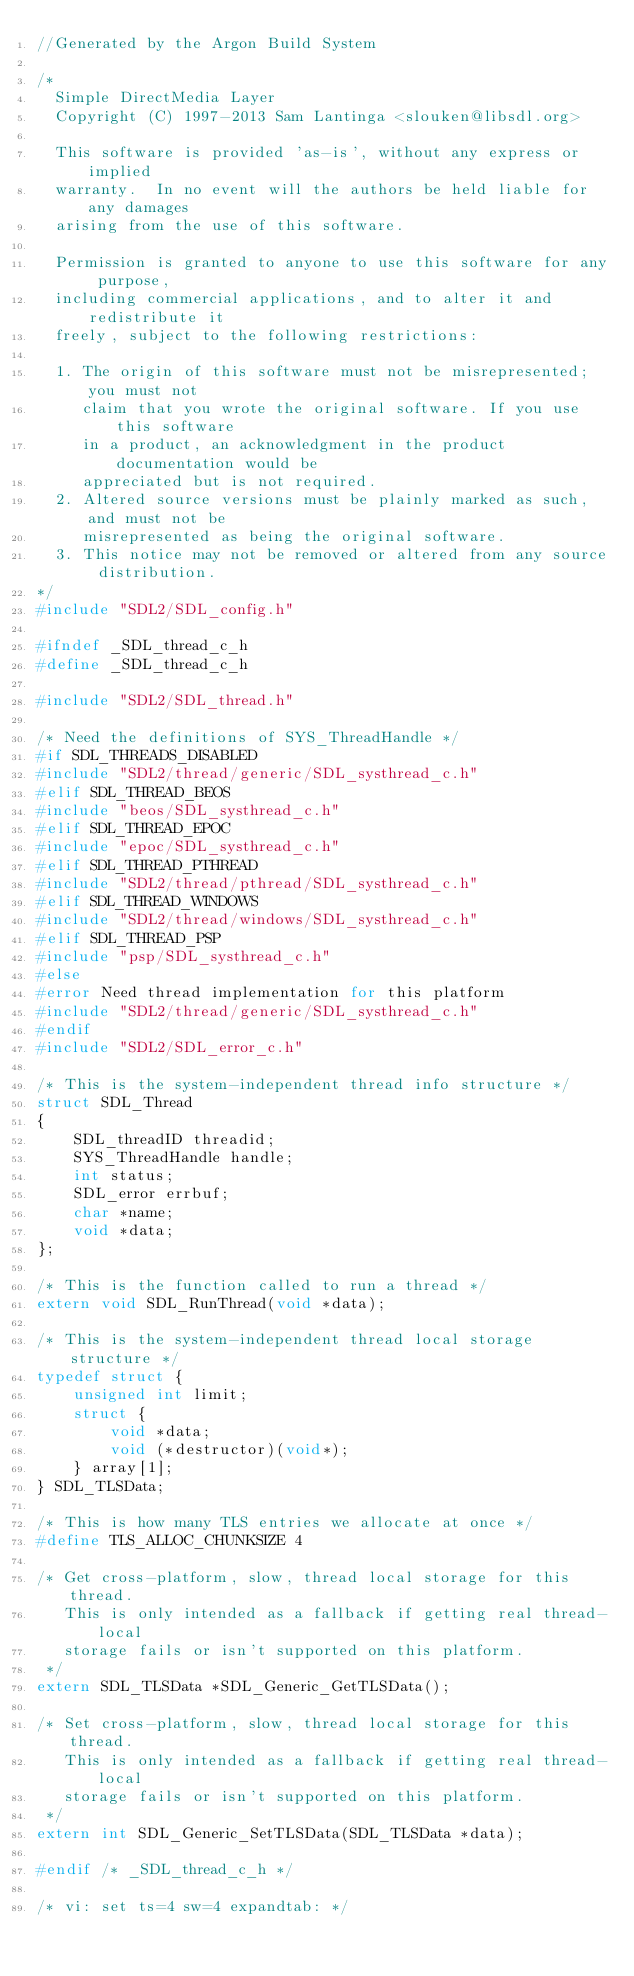Convert code to text. <code><loc_0><loc_0><loc_500><loc_500><_C_>//Generated by the Argon Build System

/*
  Simple DirectMedia Layer
  Copyright (C) 1997-2013 Sam Lantinga <slouken@libsdl.org>

  This software is provided 'as-is', without any express or implied
  warranty.  In no event will the authors be held liable for any damages
  arising from the use of this software.

  Permission is granted to anyone to use this software for any purpose,
  including commercial applications, and to alter it and redistribute it
  freely, subject to the following restrictions:

  1. The origin of this software must not be misrepresented; you must not
     claim that you wrote the original software. If you use this software
     in a product, an acknowledgment in the product documentation would be
     appreciated but is not required.
  2. Altered source versions must be plainly marked as such, and must not be
     misrepresented as being the original software.
  3. This notice may not be removed or altered from any source distribution.
*/
#include "SDL2/SDL_config.h"

#ifndef _SDL_thread_c_h
#define _SDL_thread_c_h

#include "SDL2/SDL_thread.h"

/* Need the definitions of SYS_ThreadHandle */
#if SDL_THREADS_DISABLED
#include "SDL2/thread/generic/SDL_systhread_c.h"
#elif SDL_THREAD_BEOS
#include "beos/SDL_systhread_c.h"
#elif SDL_THREAD_EPOC
#include "epoc/SDL_systhread_c.h"
#elif SDL_THREAD_PTHREAD
#include "SDL2/thread/pthread/SDL_systhread_c.h"
#elif SDL_THREAD_WINDOWS
#include "SDL2/thread/windows/SDL_systhread_c.h"
#elif SDL_THREAD_PSP
#include "psp/SDL_systhread_c.h"
#else
#error Need thread implementation for this platform
#include "SDL2/thread/generic/SDL_systhread_c.h"
#endif
#include "SDL2/SDL_error_c.h"

/* This is the system-independent thread info structure */
struct SDL_Thread
{
    SDL_threadID threadid;
    SYS_ThreadHandle handle;
    int status;
    SDL_error errbuf;
    char *name;
    void *data;
};

/* This is the function called to run a thread */
extern void SDL_RunThread(void *data);

/* This is the system-independent thread local storage structure */
typedef struct {
    unsigned int limit;
    struct {
        void *data;
        void (*destructor)(void*);
    } array[1];
} SDL_TLSData;

/* This is how many TLS entries we allocate at once */
#define TLS_ALLOC_CHUNKSIZE 4

/* Get cross-platform, slow, thread local storage for this thread.
   This is only intended as a fallback if getting real thread-local
   storage fails or isn't supported on this platform.
 */
extern SDL_TLSData *SDL_Generic_GetTLSData();

/* Set cross-platform, slow, thread local storage for this thread.
   This is only intended as a fallback if getting real thread-local
   storage fails or isn't supported on this platform.
 */
extern int SDL_Generic_SetTLSData(SDL_TLSData *data);

#endif /* _SDL_thread_c_h */

/* vi: set ts=4 sw=4 expandtab: */
</code> 